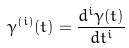<formula> <loc_0><loc_0><loc_500><loc_500>\gamma ^ { ( i ) } ( t ) = \frac { d ^ { i } \gamma ( t ) } { d t ^ { i } }</formula> 